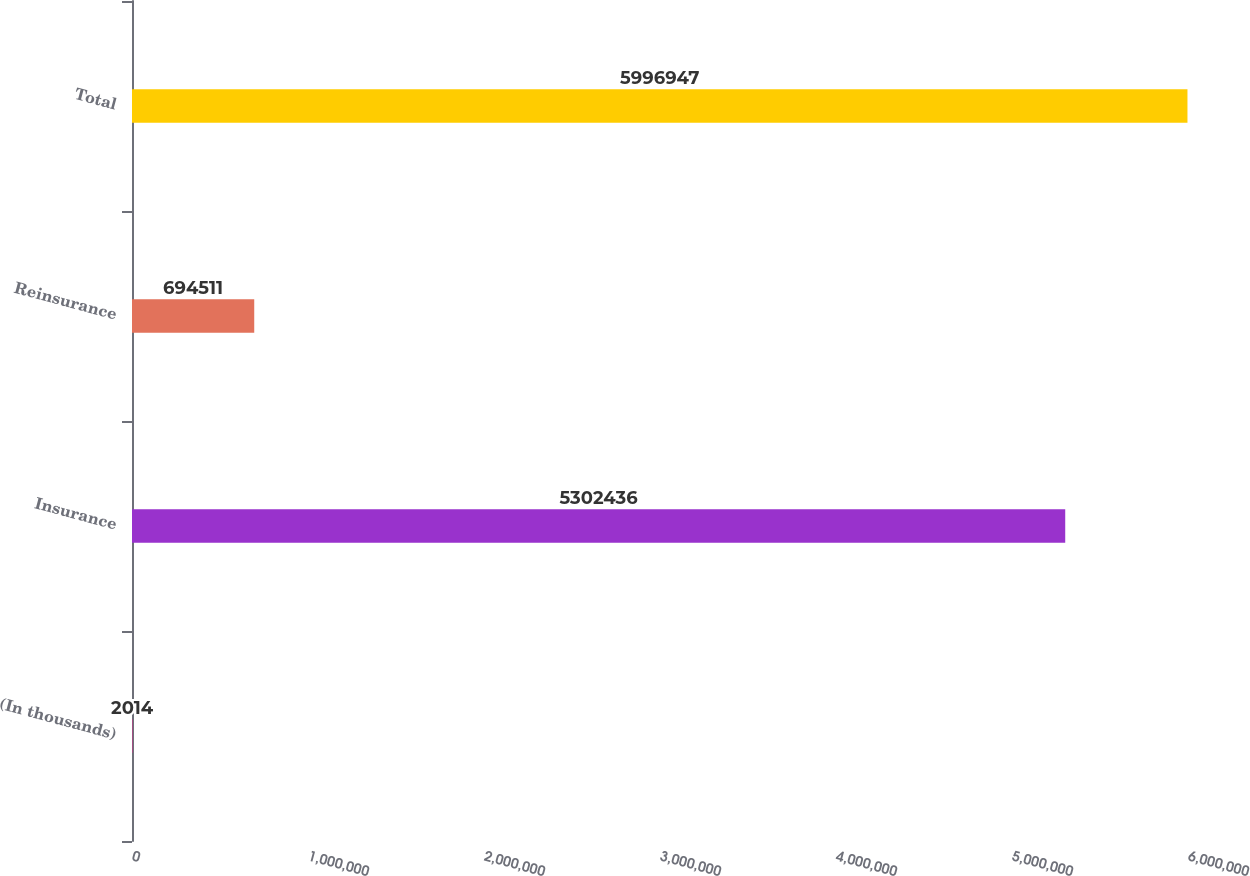Convert chart to OTSL. <chart><loc_0><loc_0><loc_500><loc_500><bar_chart><fcel>(In thousands)<fcel>Insurance<fcel>Reinsurance<fcel>Total<nl><fcel>2014<fcel>5.30244e+06<fcel>694511<fcel>5.99695e+06<nl></chart> 